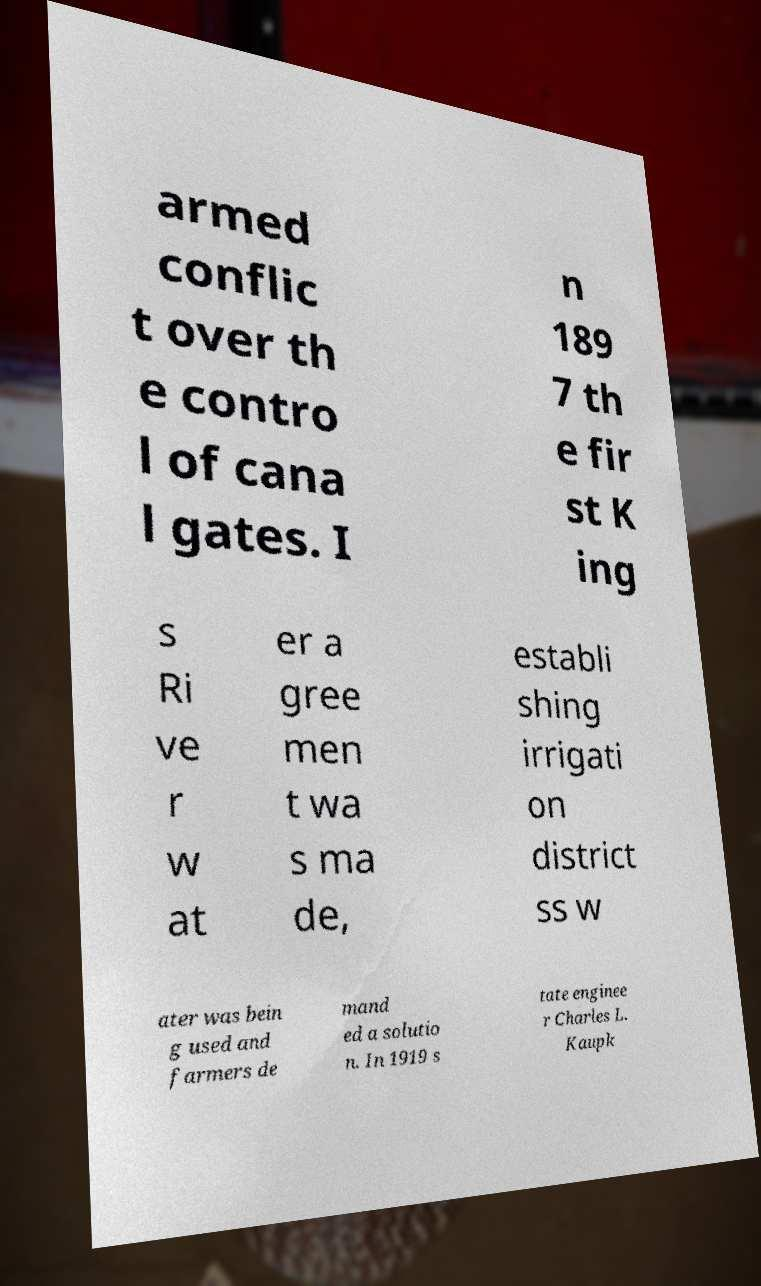For documentation purposes, I need the text within this image transcribed. Could you provide that? armed conflic t over th e contro l of cana l gates. I n 189 7 th e fir st K ing s Ri ve r w at er a gree men t wa s ma de, establi shing irrigati on district ss w ater was bein g used and farmers de mand ed a solutio n. In 1919 s tate enginee r Charles L. Kaupk 